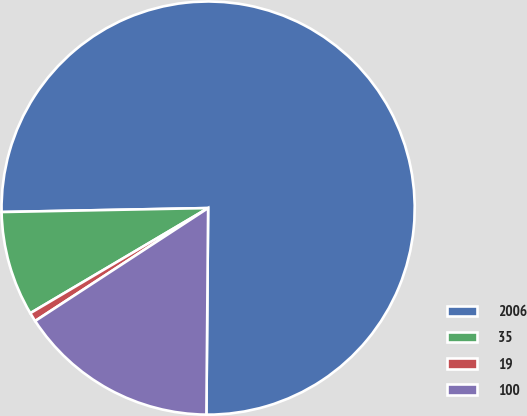<chart> <loc_0><loc_0><loc_500><loc_500><pie_chart><fcel>2006<fcel>35<fcel>19<fcel>100<nl><fcel>75.44%<fcel>8.19%<fcel>0.71%<fcel>15.66%<nl></chart> 